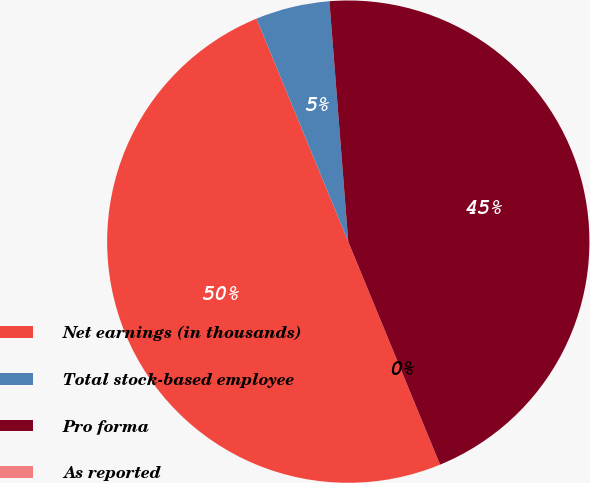<chart> <loc_0><loc_0><loc_500><loc_500><pie_chart><fcel>Net earnings (in thousands)<fcel>Total stock-based employee<fcel>Pro forma<fcel>As reported<nl><fcel>50.0%<fcel>4.97%<fcel>45.03%<fcel>0.0%<nl></chart> 